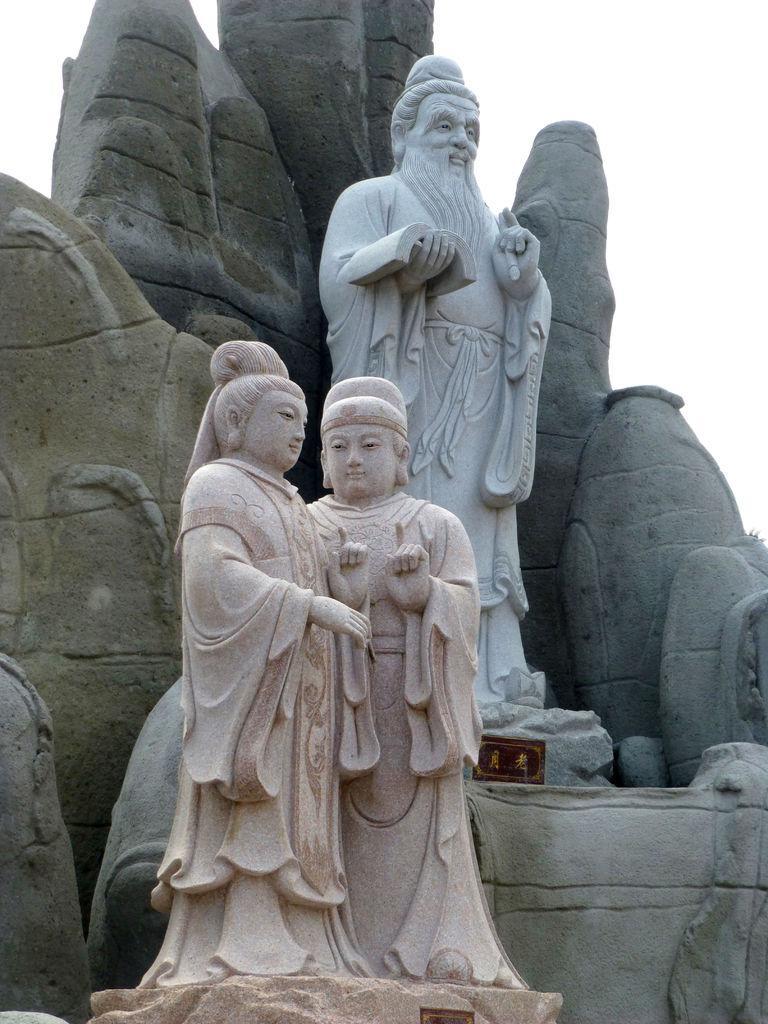How would you summarize this image in a sentence or two? In this picture I can see few statues and I can see a cloudy sky. 